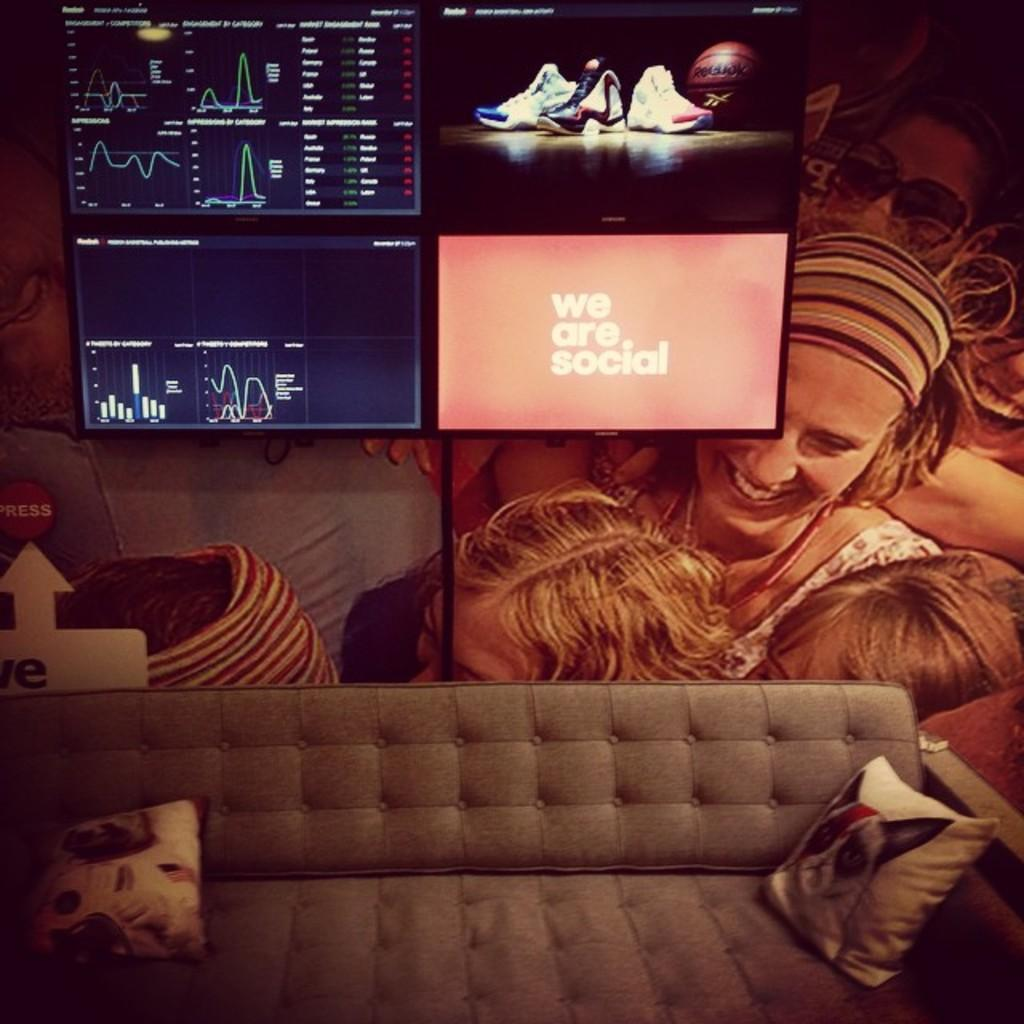How many women are sitting in the image? There are two women sitting in the image. What type of furniture can be seen in the image? There is a sofa in the image. Are there any decorative items on the sofa? Yes, there are two pillows on the sofa. What is displayed on the screen in the image? Shoes and a ball are on the screen. Is there any other object or feature in the image? Yes, there is a poster in the image. How many hearts can be seen on the poster in the image? There is no heart visible on the poster in the image. Is there a store in the image? There is no store present in the image. 